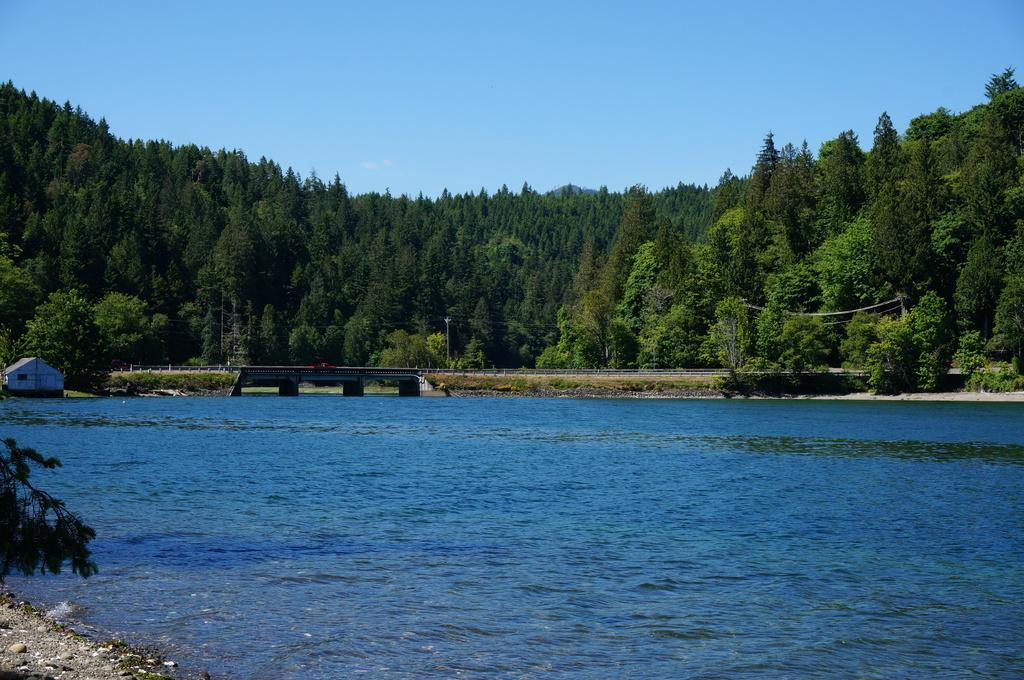What type of vegetation can be seen in the image? There are trees in the image. What structure is present in the image? There is a bridge in the image. What natural element is visible in the image? There is water visible in the image. Where is the house located in the image? The house is on the left side of the image. What can be seen in the background of the image? The sky is visible in the background of the image. Can you see any scissors being used to cut the veil in the image? There are no scissors or veil present in the image. What type of bird can be seen flying over the bridge in the image? There are no birds visible in the image; it only features trees, a bridge, water, a house, and the sky. 